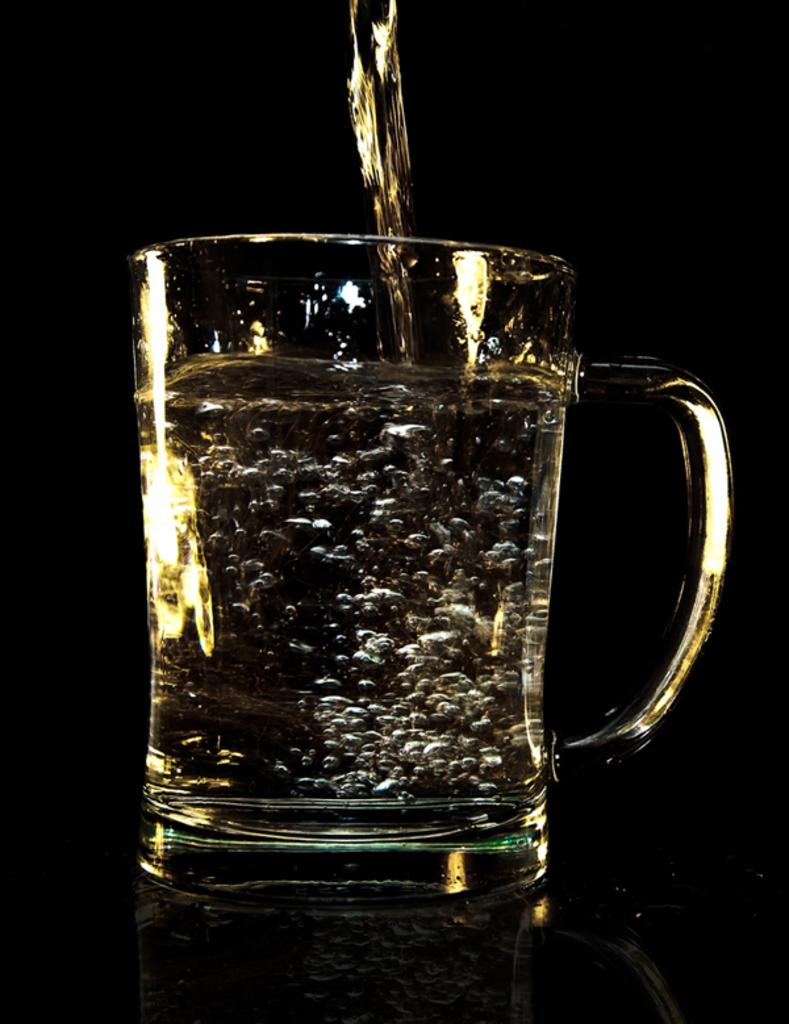What object can be seen in the image that is typically used for holding liquids? There is a glass in the image that is typically used for holding liquids. What liquid is present in the image? There is water in the image. What force is causing the rain to fall in the image? There is no rain present in the image, so there is no force causing rain to fall. 